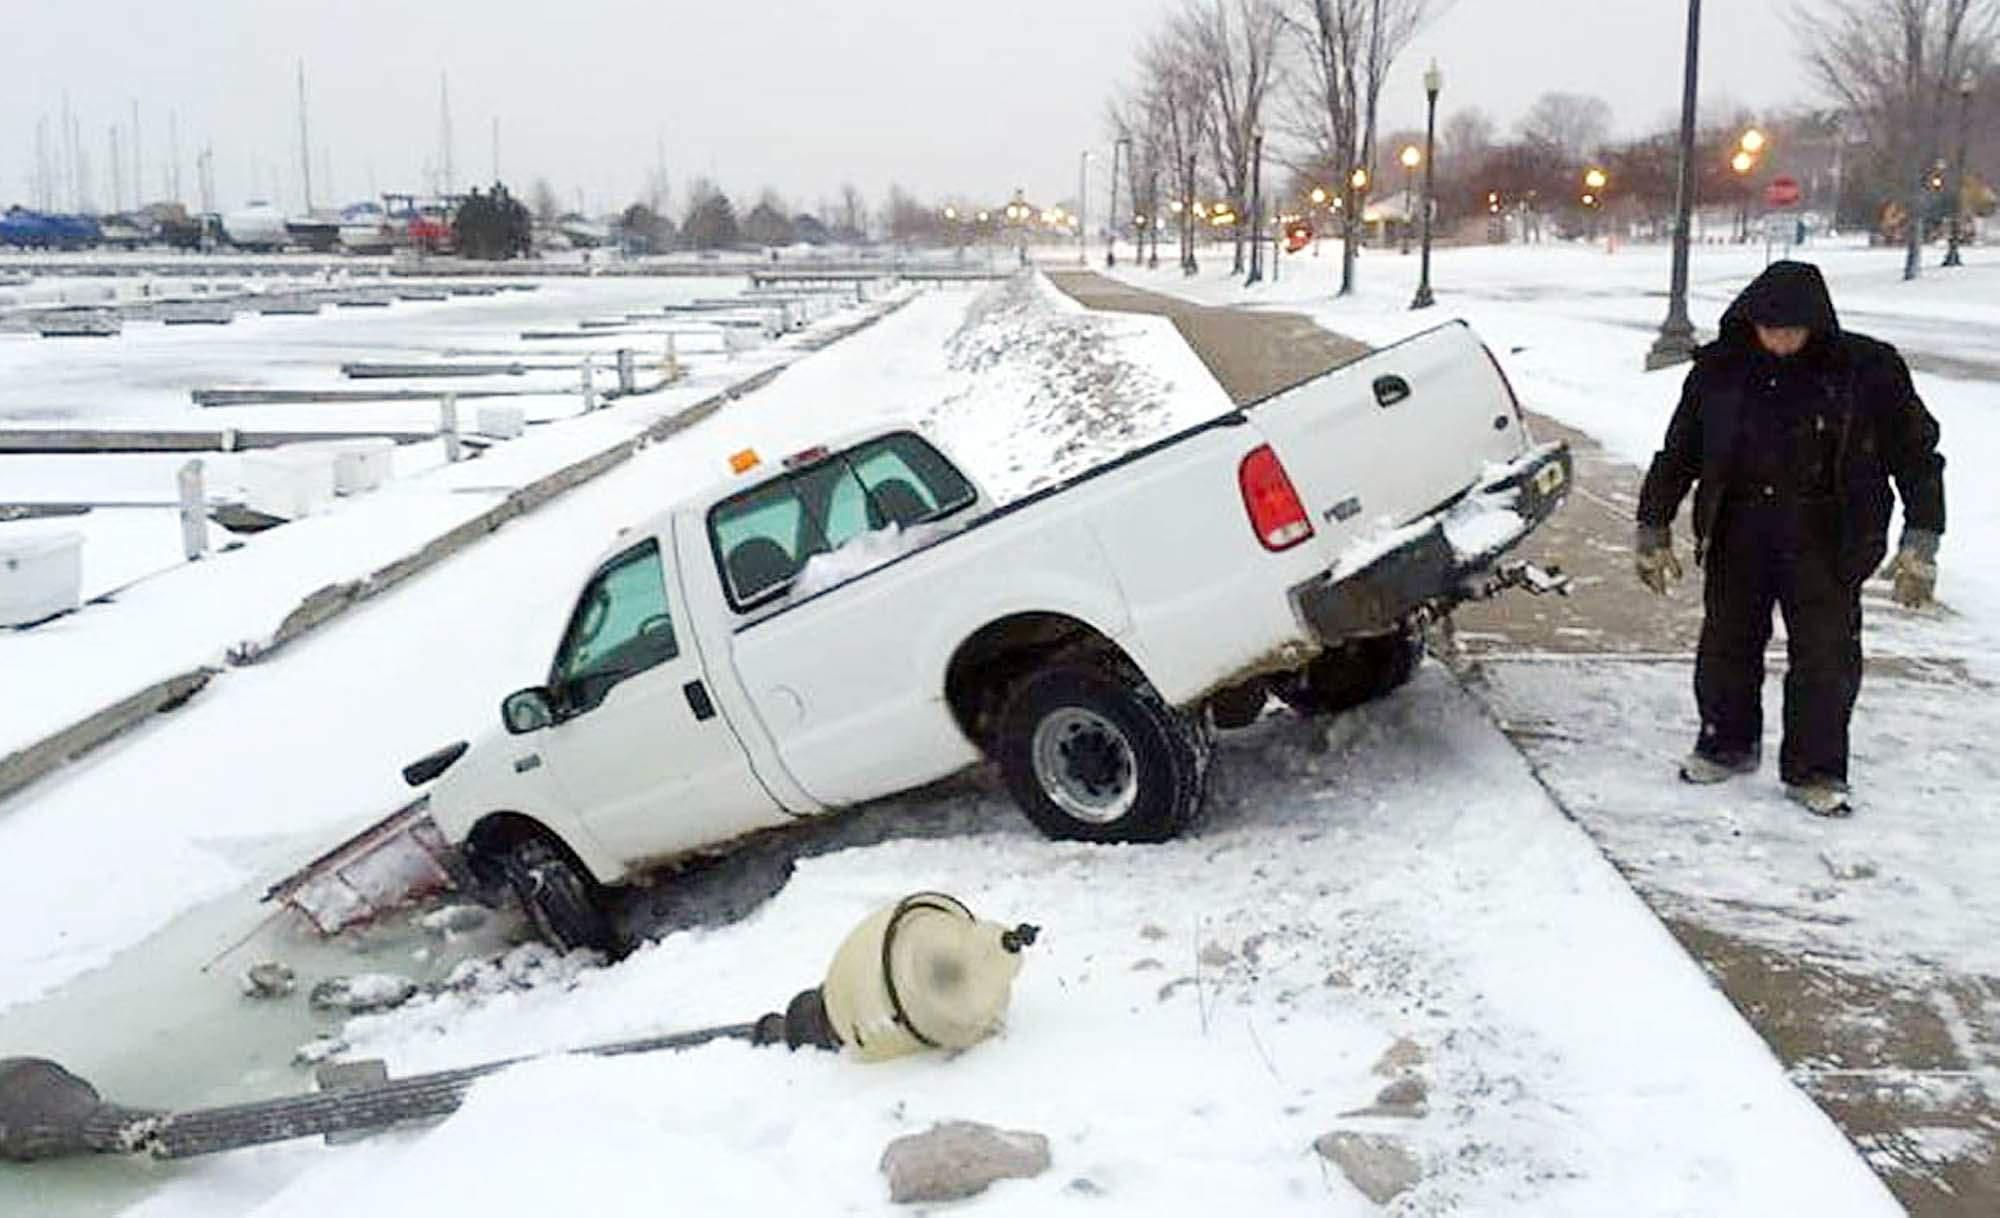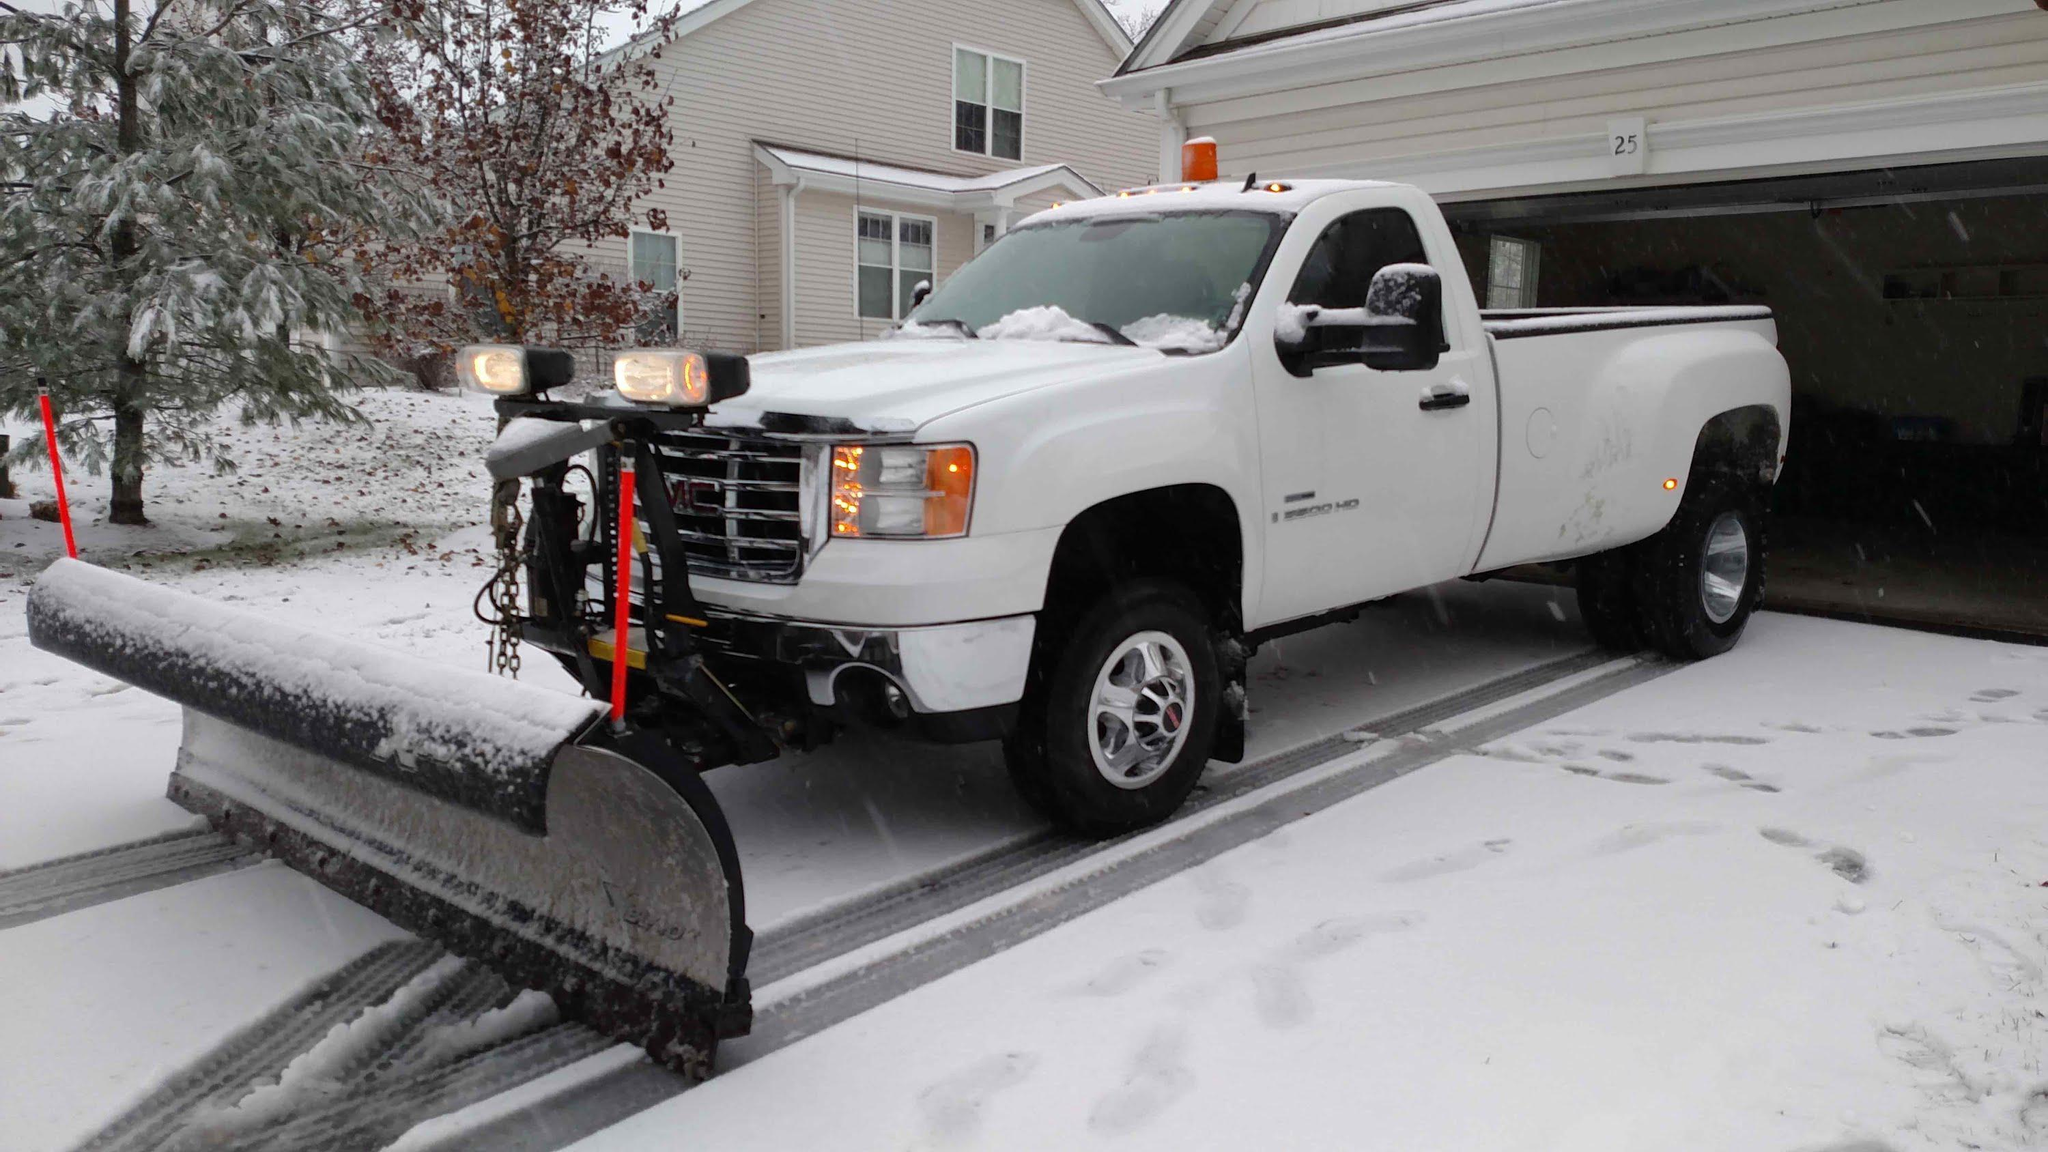The first image is the image on the left, the second image is the image on the right. Considering the images on both sides, is "At least one of the images shows a highway scene." valid? Answer yes or no. No. 